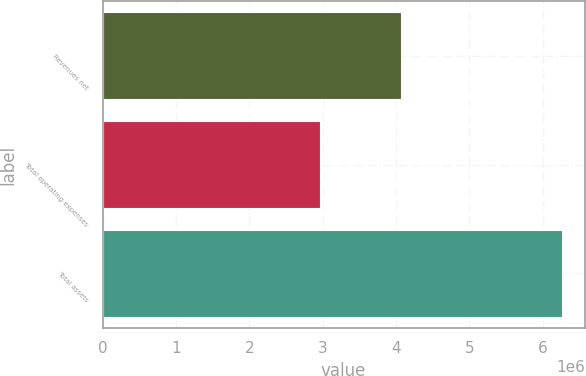Convert chart. <chart><loc_0><loc_0><loc_500><loc_500><bar_chart><fcel>Revenues net<fcel>Total operating expenses<fcel>Total assets<nl><fcel>4.0676e+06<fcel>2.95949e+06<fcel>6.26004e+06<nl></chart> 